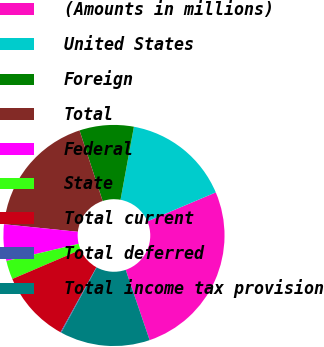Convert chart to OTSL. <chart><loc_0><loc_0><loc_500><loc_500><pie_chart><fcel>(Amounts in millions)<fcel>United States<fcel>Foreign<fcel>Total<fcel>Federal<fcel>State<fcel>Total current<fcel>Total deferred<fcel>Total income tax provision<nl><fcel>26.15%<fcel>15.74%<fcel>7.93%<fcel>18.34%<fcel>5.33%<fcel>2.73%<fcel>10.53%<fcel>0.12%<fcel>13.14%<nl></chart> 